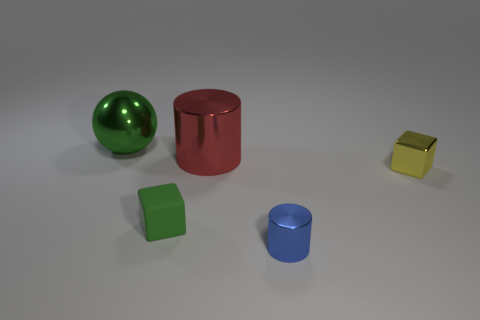Add 1 blue shiny cylinders. How many objects exist? 6 Subtract all balls. How many objects are left? 4 Subtract 0 red blocks. How many objects are left? 5 Subtract all yellow objects. Subtract all small yellow blocks. How many objects are left? 3 Add 3 small yellow metallic cubes. How many small yellow metallic cubes are left? 4 Add 2 metallic cubes. How many metallic cubes exist? 3 